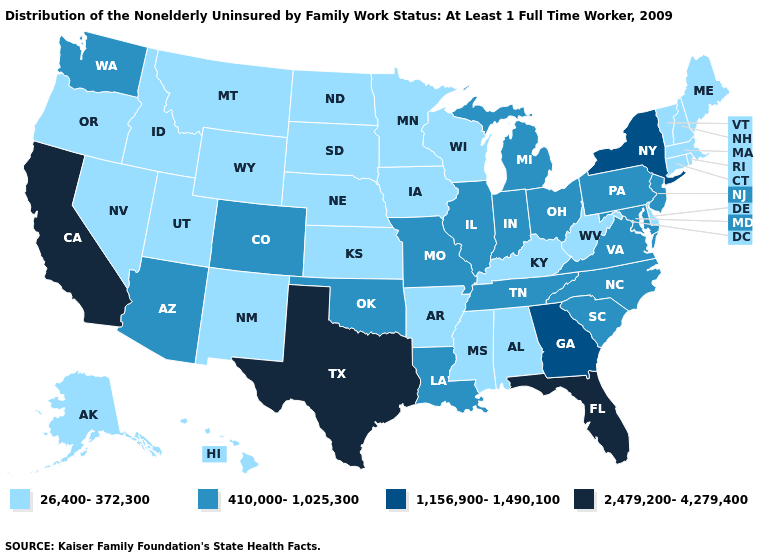What is the lowest value in the USA?
Give a very brief answer. 26,400-372,300. Name the states that have a value in the range 2,479,200-4,279,400?
Answer briefly. California, Florida, Texas. Name the states that have a value in the range 410,000-1,025,300?
Short answer required. Arizona, Colorado, Illinois, Indiana, Louisiana, Maryland, Michigan, Missouri, New Jersey, North Carolina, Ohio, Oklahoma, Pennsylvania, South Carolina, Tennessee, Virginia, Washington. Which states have the lowest value in the USA?
Answer briefly. Alabama, Alaska, Arkansas, Connecticut, Delaware, Hawaii, Idaho, Iowa, Kansas, Kentucky, Maine, Massachusetts, Minnesota, Mississippi, Montana, Nebraska, Nevada, New Hampshire, New Mexico, North Dakota, Oregon, Rhode Island, South Dakota, Utah, Vermont, West Virginia, Wisconsin, Wyoming. Does Alaska have the lowest value in the West?
Quick response, please. Yes. What is the lowest value in the USA?
Be succinct. 26,400-372,300. How many symbols are there in the legend?
Give a very brief answer. 4. What is the value of Arizona?
Short answer required. 410,000-1,025,300. Name the states that have a value in the range 410,000-1,025,300?
Answer briefly. Arizona, Colorado, Illinois, Indiana, Louisiana, Maryland, Michigan, Missouri, New Jersey, North Carolina, Ohio, Oklahoma, Pennsylvania, South Carolina, Tennessee, Virginia, Washington. What is the value of West Virginia?
Concise answer only. 26,400-372,300. Is the legend a continuous bar?
Short answer required. No. Name the states that have a value in the range 26,400-372,300?
Quick response, please. Alabama, Alaska, Arkansas, Connecticut, Delaware, Hawaii, Idaho, Iowa, Kansas, Kentucky, Maine, Massachusetts, Minnesota, Mississippi, Montana, Nebraska, Nevada, New Hampshire, New Mexico, North Dakota, Oregon, Rhode Island, South Dakota, Utah, Vermont, West Virginia, Wisconsin, Wyoming. Does the first symbol in the legend represent the smallest category?
Keep it brief. Yes. Name the states that have a value in the range 410,000-1,025,300?
Give a very brief answer. Arizona, Colorado, Illinois, Indiana, Louisiana, Maryland, Michigan, Missouri, New Jersey, North Carolina, Ohio, Oklahoma, Pennsylvania, South Carolina, Tennessee, Virginia, Washington. Among the states that border Vermont , which have the highest value?
Short answer required. New York. 